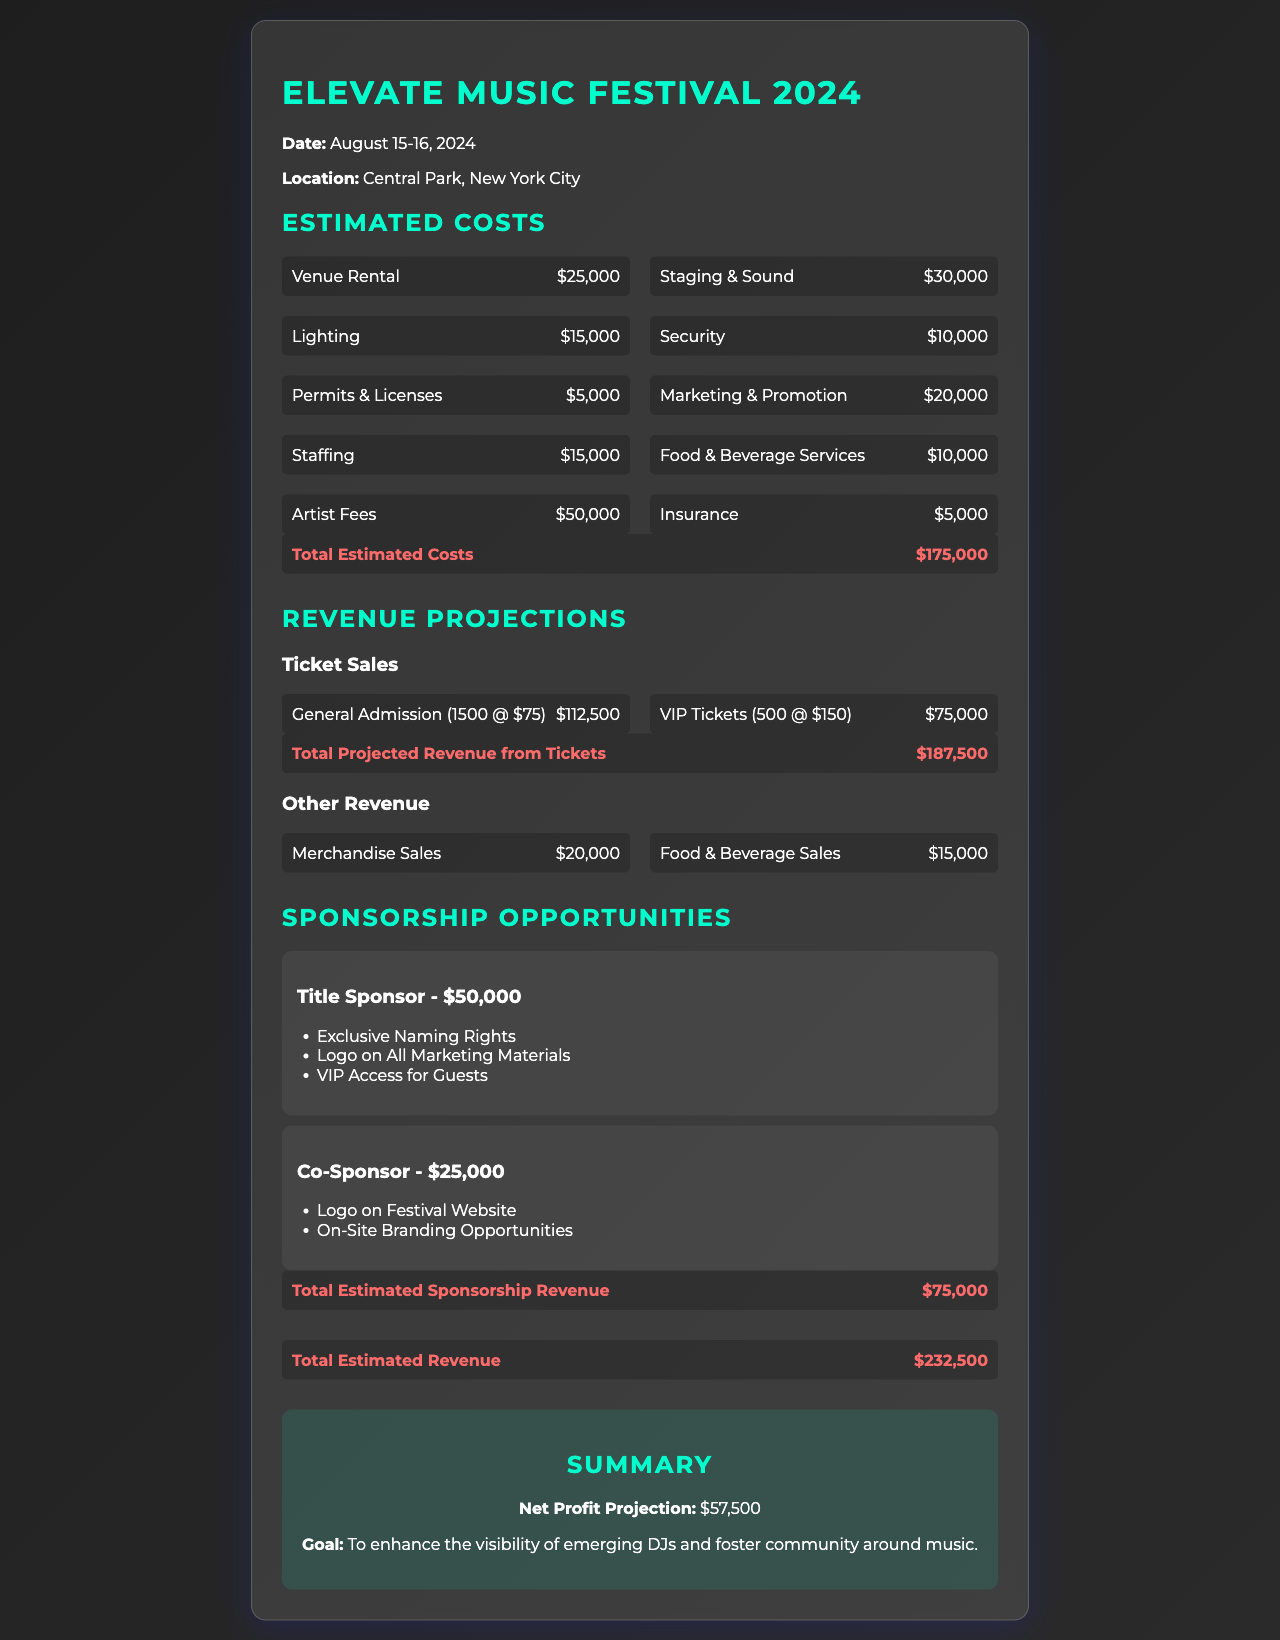what is the date of the festival? The date of the festival is mentioned clearly at the top of the document as August 15-16, 2024.
Answer: August 15-16, 2024 where is the event taking place? The location of the festival is stated in the document as Central Park, New York City.
Answer: Central Park, New York City what is the total estimated cost? The total estimated costs are summarized towards the end of the cost section, which adds up to $175,000.
Answer: $175,000 how much is the revenue from general admission tickets? The document lists the revenue from general admission tickets as $112,500.
Answer: $112,500 what is one benefit of being a Title Sponsor? The document outlines benefits of the Title Sponsor, which includes exclusive naming rights.
Answer: Exclusive Naming Rights what is the projection for net profit? The summary section in the document indicates a net profit projection of $57,500.
Answer: $57,500 how much can be earned from sponsorships? The document calculates the total estimated sponsorship revenue to be $75,000.
Answer: $75,000 which category has the highest cost? The document details the artist fees as the highest individual cost, listed at $50,000.
Answer: Artist Fees what is the total projected revenue from tickets? The document specifies that the total projected revenue from tickets is $187,500.
Answer: $187,500 